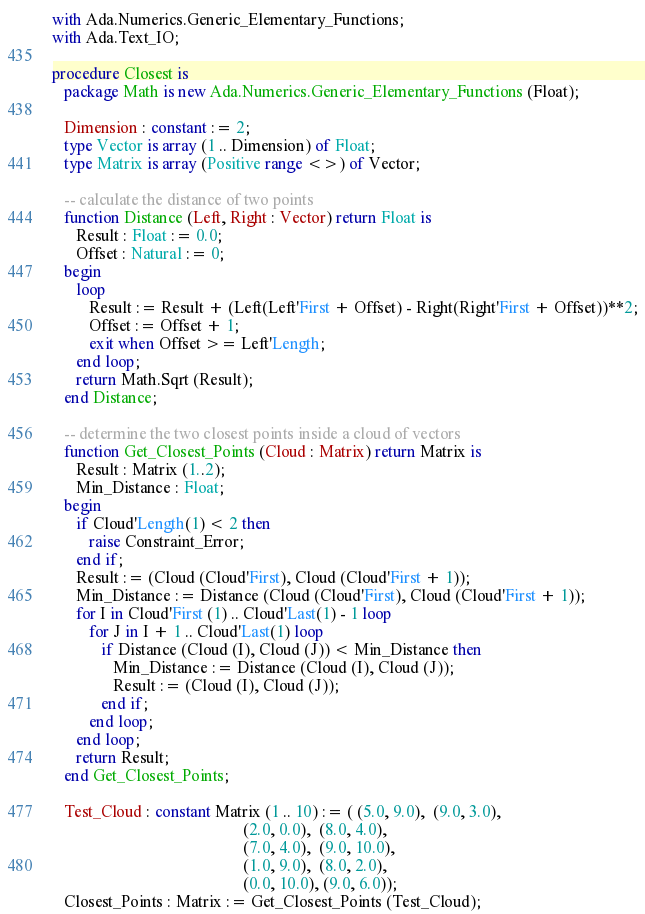Convert code to text. <code><loc_0><loc_0><loc_500><loc_500><_Ada_>with Ada.Numerics.Generic_Elementary_Functions;
with Ada.Text_IO;

procedure Closest is
   package Math is new Ada.Numerics.Generic_Elementary_Functions (Float);

   Dimension : constant := 2;
   type Vector is array (1 .. Dimension) of Float;
   type Matrix is array (Positive range <>) of Vector;

   -- calculate the distance of two points
   function Distance (Left, Right : Vector) return Float is
      Result : Float := 0.0;
      Offset : Natural := 0;
   begin
      loop
         Result := Result + (Left(Left'First + Offset) - Right(Right'First + Offset))**2;
         Offset := Offset + 1;
         exit when Offset >= Left'Length;
      end loop;
      return Math.Sqrt (Result);
   end Distance;

   -- determine the two closest points inside a cloud of vectors
   function Get_Closest_Points (Cloud : Matrix) return Matrix is
      Result : Matrix (1..2);
      Min_Distance : Float;
   begin
      if Cloud'Length(1) < 2 then
         raise Constraint_Error;
      end if;
      Result := (Cloud (Cloud'First), Cloud (Cloud'First + 1));
      Min_Distance := Distance (Cloud (Cloud'First), Cloud (Cloud'First + 1));
      for I in Cloud'First (1) .. Cloud'Last(1) - 1 loop
         for J in I + 1 .. Cloud'Last(1) loop
            if Distance (Cloud (I), Cloud (J)) < Min_Distance then
               Min_Distance := Distance (Cloud (I), Cloud (J));
               Result := (Cloud (I), Cloud (J));
            end if;
         end loop;
      end loop;
      return Result;
   end Get_Closest_Points;

   Test_Cloud : constant Matrix (1 .. 10) := ( (5.0, 9.0),  (9.0, 3.0),
                                               (2.0, 0.0),  (8.0, 4.0),
                                               (7.0, 4.0),  (9.0, 10.0),
                                               (1.0, 9.0),  (8.0, 2.0),
                                               (0.0, 10.0), (9.0, 6.0));
   Closest_Points : Matrix := Get_Closest_Points (Test_Cloud);
</code> 